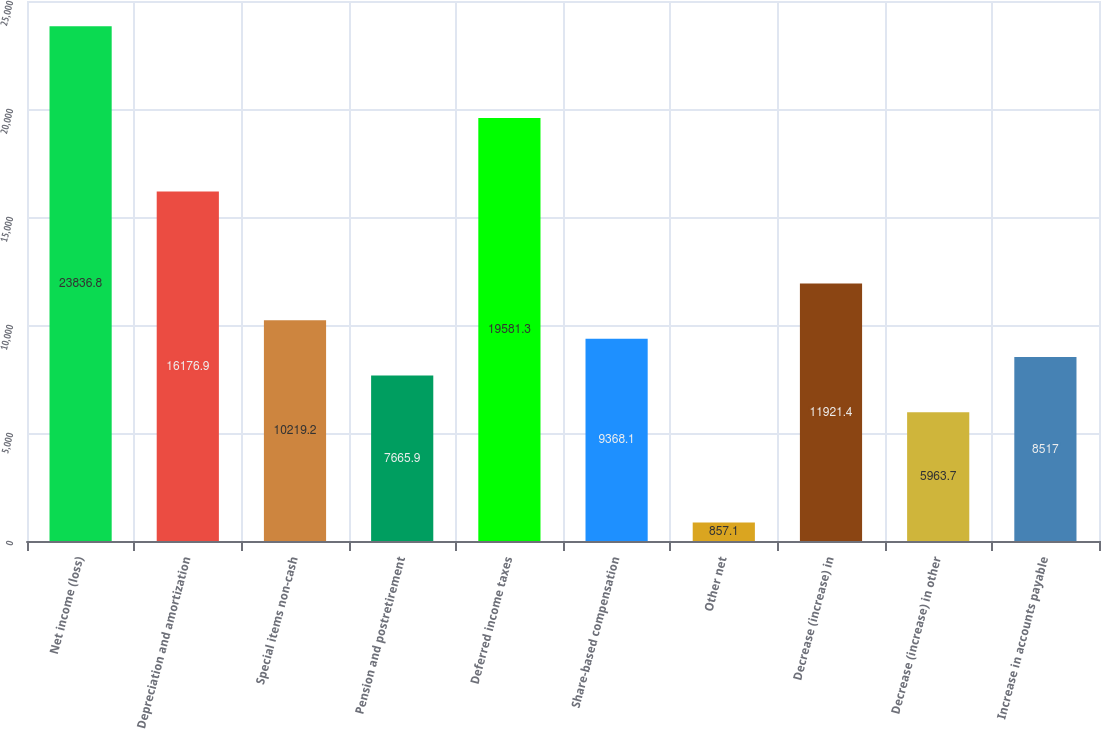Convert chart to OTSL. <chart><loc_0><loc_0><loc_500><loc_500><bar_chart><fcel>Net income (loss)<fcel>Depreciation and amortization<fcel>Special items non-cash<fcel>Pension and postretirement<fcel>Deferred income taxes<fcel>Share-based compensation<fcel>Other net<fcel>Decrease (increase) in<fcel>Decrease (increase) in other<fcel>Increase in accounts payable<nl><fcel>23836.8<fcel>16176.9<fcel>10219.2<fcel>7665.9<fcel>19581.3<fcel>9368.1<fcel>857.1<fcel>11921.4<fcel>5963.7<fcel>8517<nl></chart> 